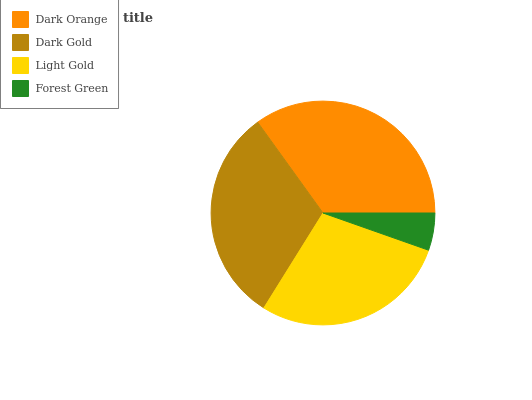Is Forest Green the minimum?
Answer yes or no. Yes. Is Dark Orange the maximum?
Answer yes or no. Yes. Is Dark Gold the minimum?
Answer yes or no. No. Is Dark Gold the maximum?
Answer yes or no. No. Is Dark Orange greater than Dark Gold?
Answer yes or no. Yes. Is Dark Gold less than Dark Orange?
Answer yes or no. Yes. Is Dark Gold greater than Dark Orange?
Answer yes or no. No. Is Dark Orange less than Dark Gold?
Answer yes or no. No. Is Dark Gold the high median?
Answer yes or no. Yes. Is Light Gold the low median?
Answer yes or no. Yes. Is Forest Green the high median?
Answer yes or no. No. Is Dark Orange the low median?
Answer yes or no. No. 